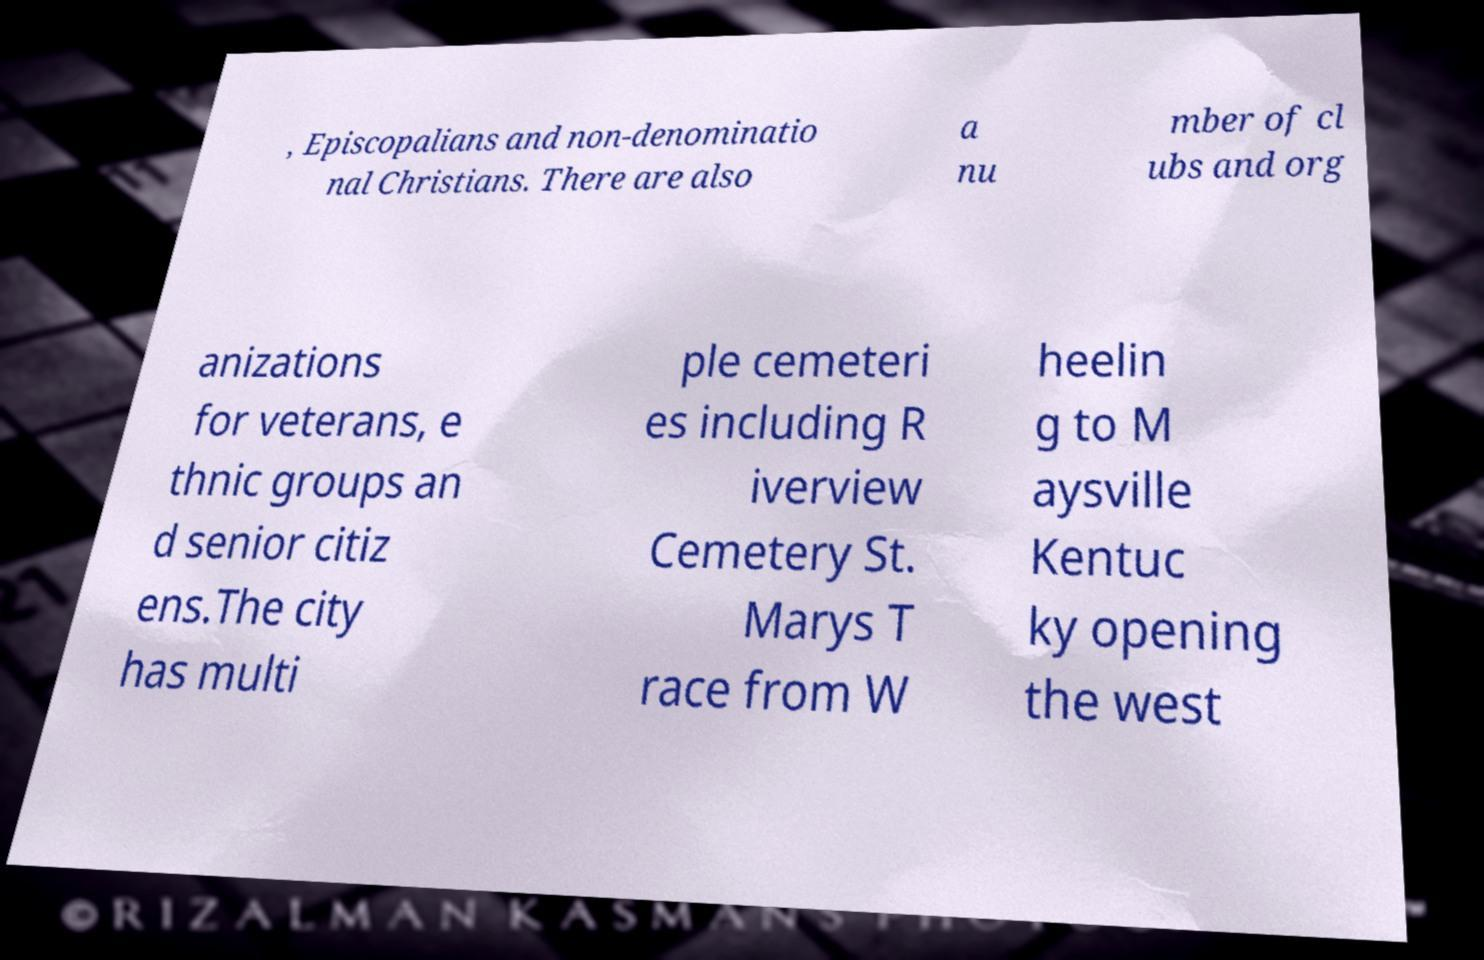Can you accurately transcribe the text from the provided image for me? , Episcopalians and non-denominatio nal Christians. There are also a nu mber of cl ubs and org anizations for veterans, e thnic groups an d senior citiz ens.The city has multi ple cemeteri es including R iverview Cemetery St. Marys T race from W heelin g to M aysville Kentuc ky opening the west 